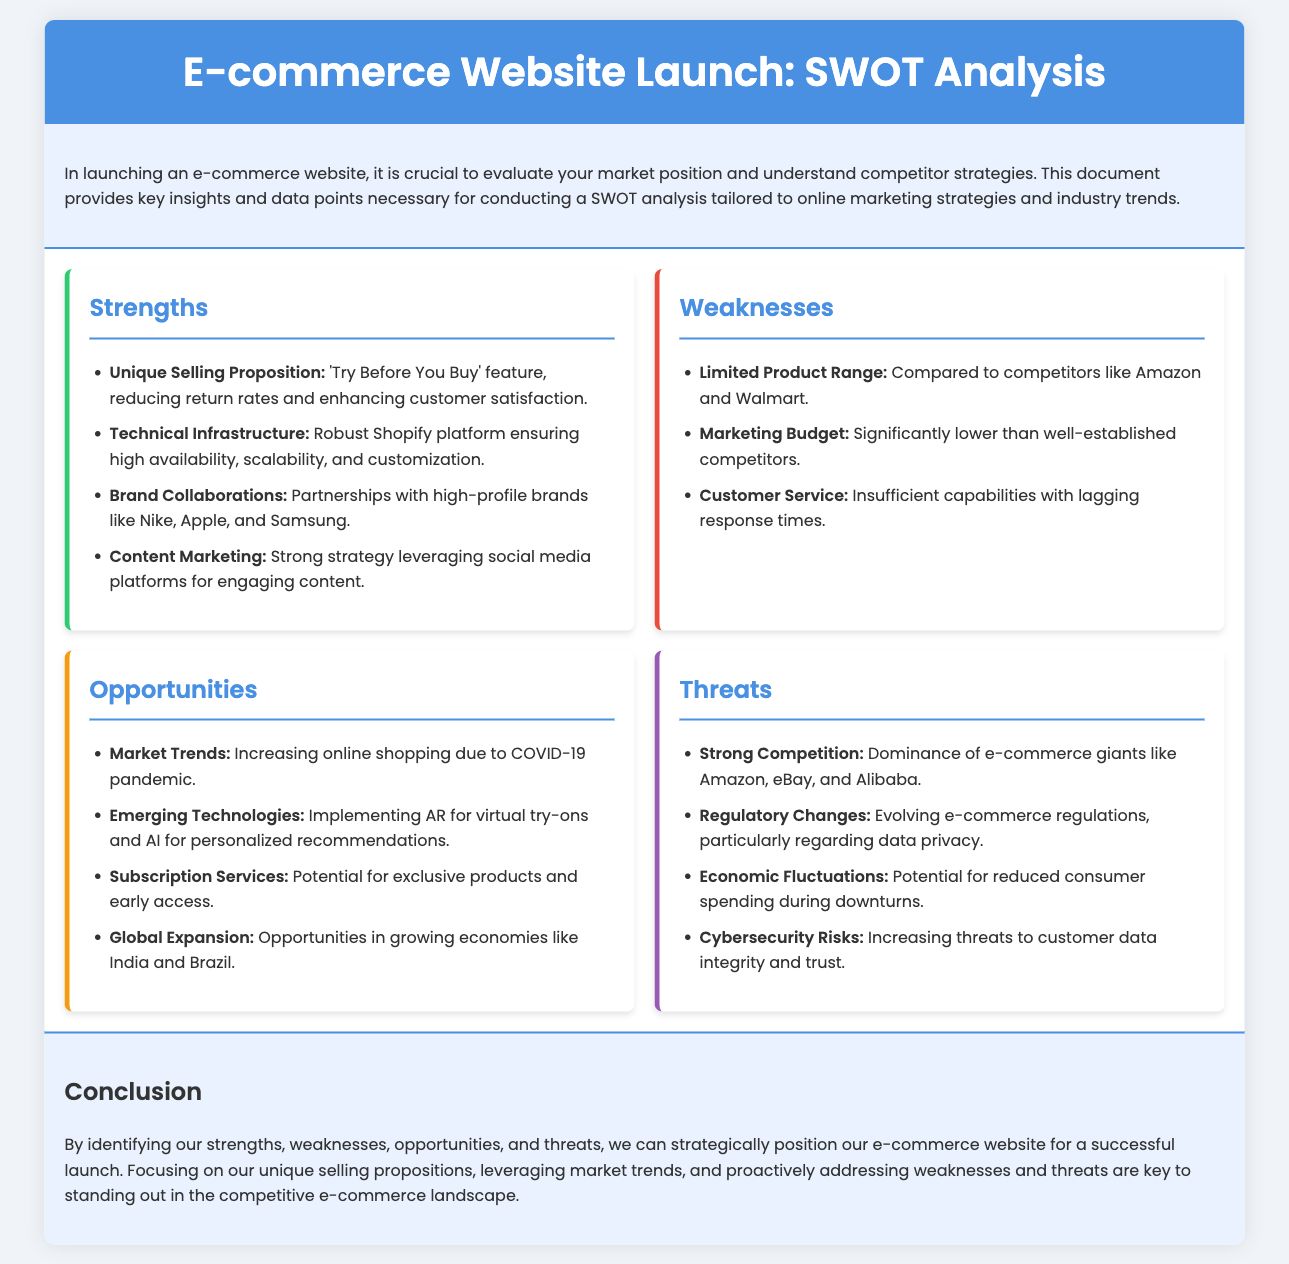What is the unique selling proposition? The unique selling proposition is outlined as a specific feature of the e-commerce site that differentiates it from competitors.
Answer: 'Try Before You Buy' feature What platform is used for technical infrastructure? The document specifies the platform used for the e-commerce website's technical infrastructure, focusing on its robustness and reliability.
Answer: Shopify Which brands are mentioned in collaborations? The document lists specific high-profile brands that the e-commerce site partners with, highlighting its brand collaborations.
Answer: Nike, Apple, and Samsung What is one of the key weaknesses related to the marketing budget? The document identifies a specific area of concern regarding the financial limitations compared to competitors.
Answer: Significantly lower What opportunity is highlighted for global expansion? The document mentions specific countries where there are growing opportunities for the e-commerce site to expand.
Answer: India and Brazil What is a major threat from the competitive landscape? The document emphasizes the presence of specific competitors that dominate the e-commerce market and pose a threat.
Answer: Amazon, eBay, and Alibaba How does the SWOT analysis benefit the e-commerce launch? The conclusion summarizes the purpose of the SWOT analysis and its implications for strategic positioning of the e-commerce website.
Answer: Strategically position What emerging technology is mentioned for enhancing customer experience? The document refers to a specific technology that could be used to improve user interaction with products on the website.
Answer: AR for virtual try-ons What is a concern related to data handling? The document details particular risks associated with handling customer information in the e-commerce space, highlighting regulatory issues.
Answer: Data privacy 